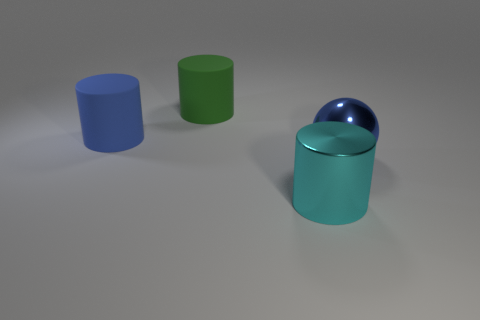There is a metallic object that is in front of the ball; is it the same shape as the blue object in front of the blue matte cylinder?
Give a very brief answer. No. What number of cylinders are blue metallic things or tiny metal objects?
Your answer should be very brief. 0. What material is the large thing that is right of the thing that is in front of the big shiny thing that is on the right side of the cyan shiny object?
Offer a very short reply. Metal. There is a rubber cylinder that is the same color as the metal ball; what size is it?
Make the answer very short. Large. Are there more big spheres that are behind the large blue cylinder than big green rubber cylinders?
Offer a terse response. No. Is there another big ball of the same color as the metal ball?
Your response must be concise. No. What color is the metallic sphere that is the same size as the green rubber thing?
Your answer should be very brief. Blue. How many large objects are in front of the shiny thing that is behind the big shiny cylinder?
Your response must be concise. 1. How many things are cylinders behind the big sphere or big blue rubber objects?
Provide a succinct answer. 2. What number of balls are made of the same material as the large green cylinder?
Your answer should be very brief. 0. 